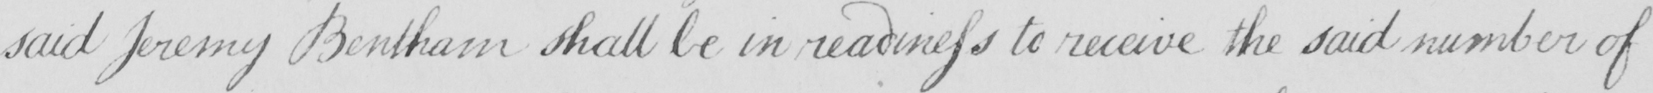What does this handwritten line say? said Jeremy Bentham shall be in readiness to receive the said number of 